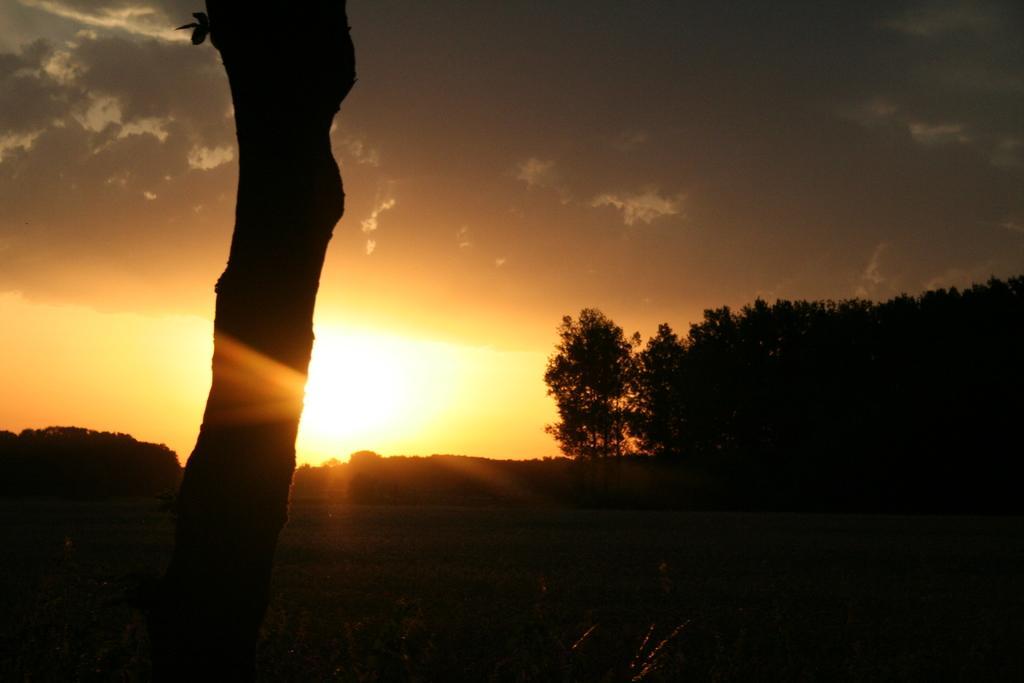In one or two sentences, can you explain what this image depicts? In this image I can see a trunk. Background I can see trees, sun and sky is in gray color. 